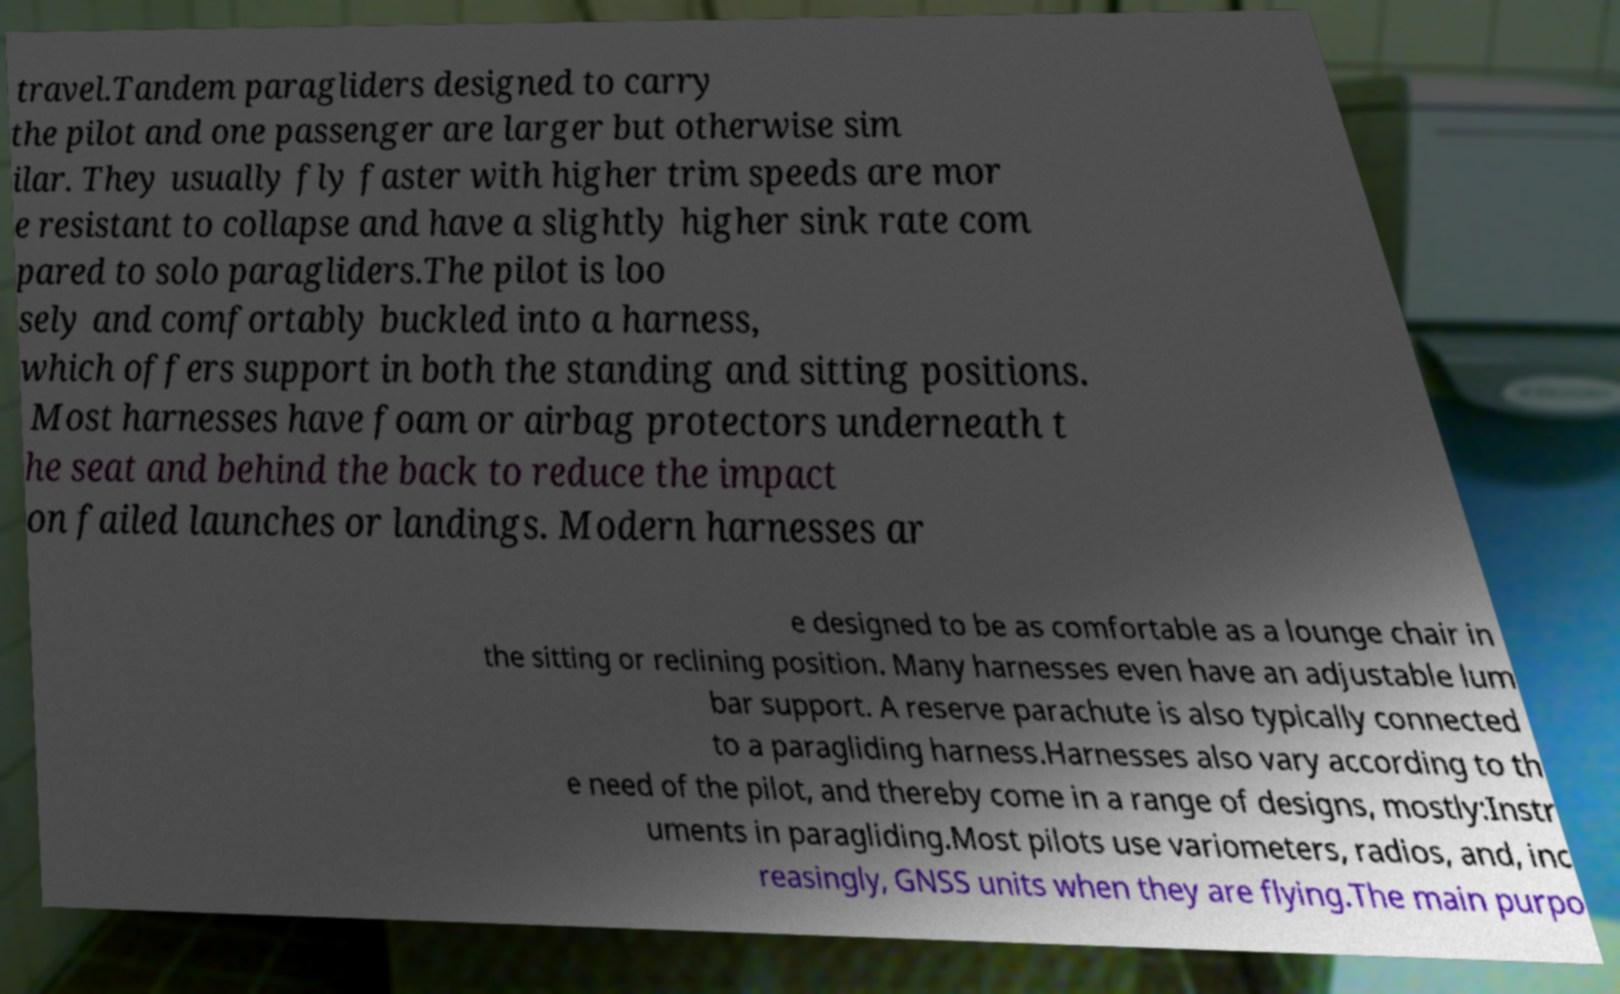Could you assist in decoding the text presented in this image and type it out clearly? travel.Tandem paragliders designed to carry the pilot and one passenger are larger but otherwise sim ilar. They usually fly faster with higher trim speeds are mor e resistant to collapse and have a slightly higher sink rate com pared to solo paragliders.The pilot is loo sely and comfortably buckled into a harness, which offers support in both the standing and sitting positions. Most harnesses have foam or airbag protectors underneath t he seat and behind the back to reduce the impact on failed launches or landings. Modern harnesses ar e designed to be as comfortable as a lounge chair in the sitting or reclining position. Many harnesses even have an adjustable lum bar support. A reserve parachute is also typically connected to a paragliding harness.Harnesses also vary according to th e need of the pilot, and thereby come in a range of designs, mostly:Instr uments in paragliding.Most pilots use variometers, radios, and, inc reasingly, GNSS units when they are flying.The main purpo 